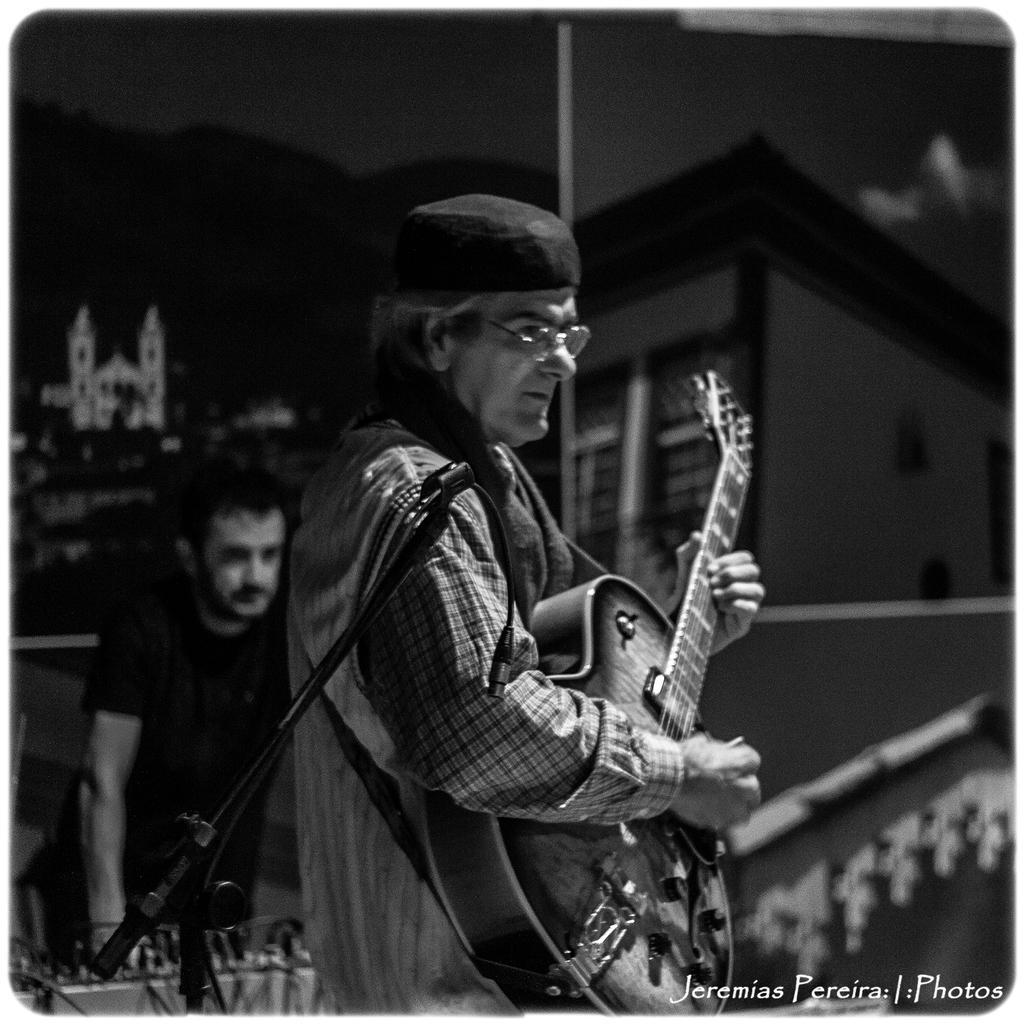Can you describe this image briefly? a person is standing playing guitar. behind him there is another person. in the front microphone is present. 